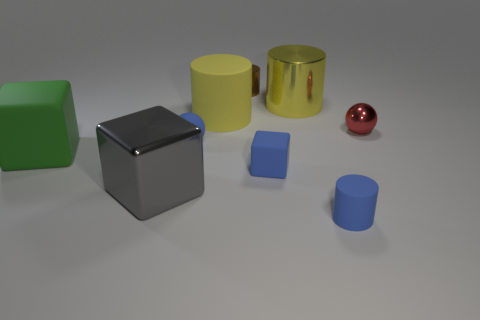There is another large matte thing that is the same shape as the gray object; what color is it?
Provide a short and direct response. Green. There is a object in front of the gray thing; is its size the same as the yellow rubber thing?
Your answer should be very brief. No. What is the shape of the shiny thing that is the same color as the big rubber cylinder?
Ensure brevity in your answer.  Cylinder. How many small green cubes have the same material as the red object?
Offer a terse response. 0. What material is the blue thing that is behind the large block behind the big shiny thing that is in front of the large matte cylinder made of?
Give a very brief answer. Rubber. There is a large rubber thing to the left of the big rubber object that is behind the tiny red metal object; what is its color?
Give a very brief answer. Green. The matte cylinder that is the same size as the brown metallic object is what color?
Offer a very short reply. Blue. What number of big things are either blue balls or cyan shiny objects?
Give a very brief answer. 0. Is the number of large objects that are behind the big shiny cube greater than the number of brown metal objects that are in front of the big green matte object?
Provide a short and direct response. Yes. What size is the rubber thing that is the same color as the big shiny cylinder?
Provide a succinct answer. Large. 